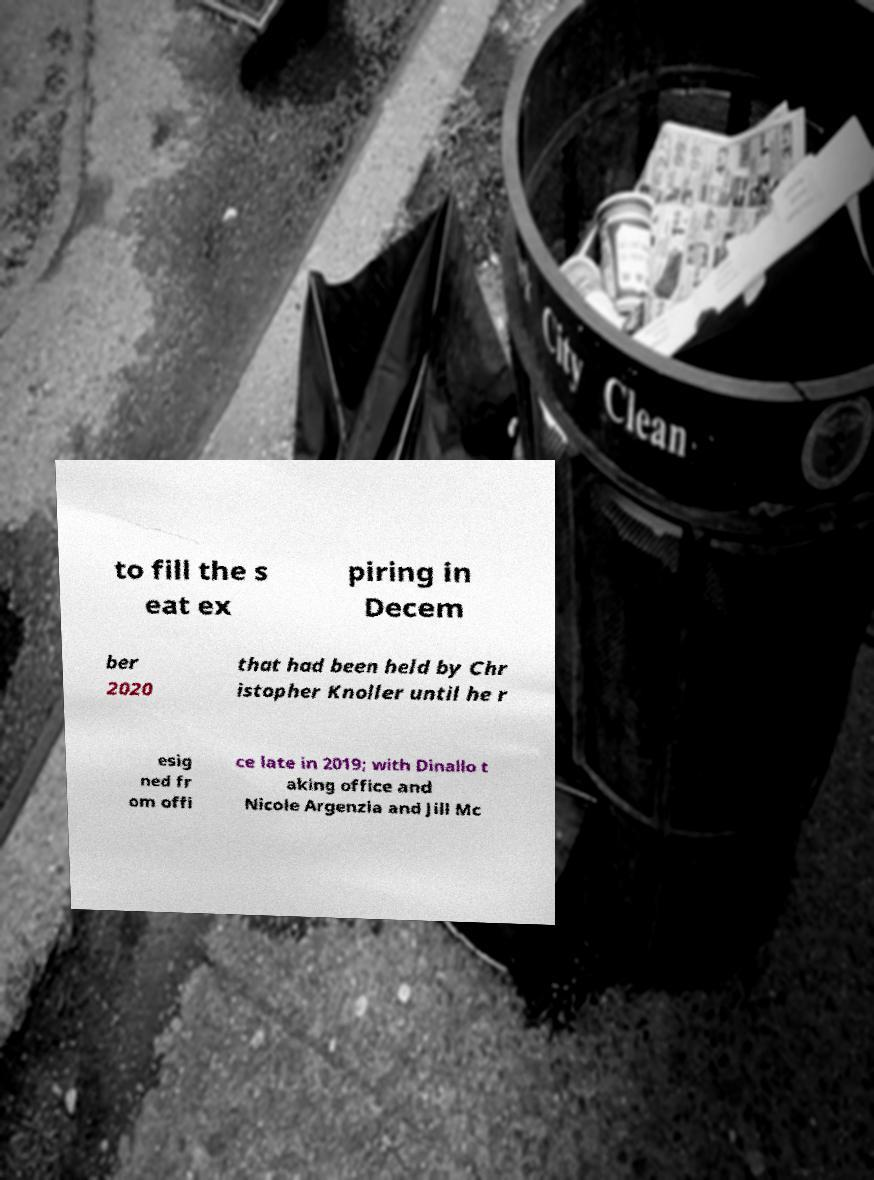Can you read and provide the text displayed in the image?This photo seems to have some interesting text. Can you extract and type it out for me? to fill the s eat ex piring in Decem ber 2020 that had been held by Chr istopher Knoller until he r esig ned fr om offi ce late in 2019; with Dinallo t aking office and Nicole Argenzia and Jill Mc 